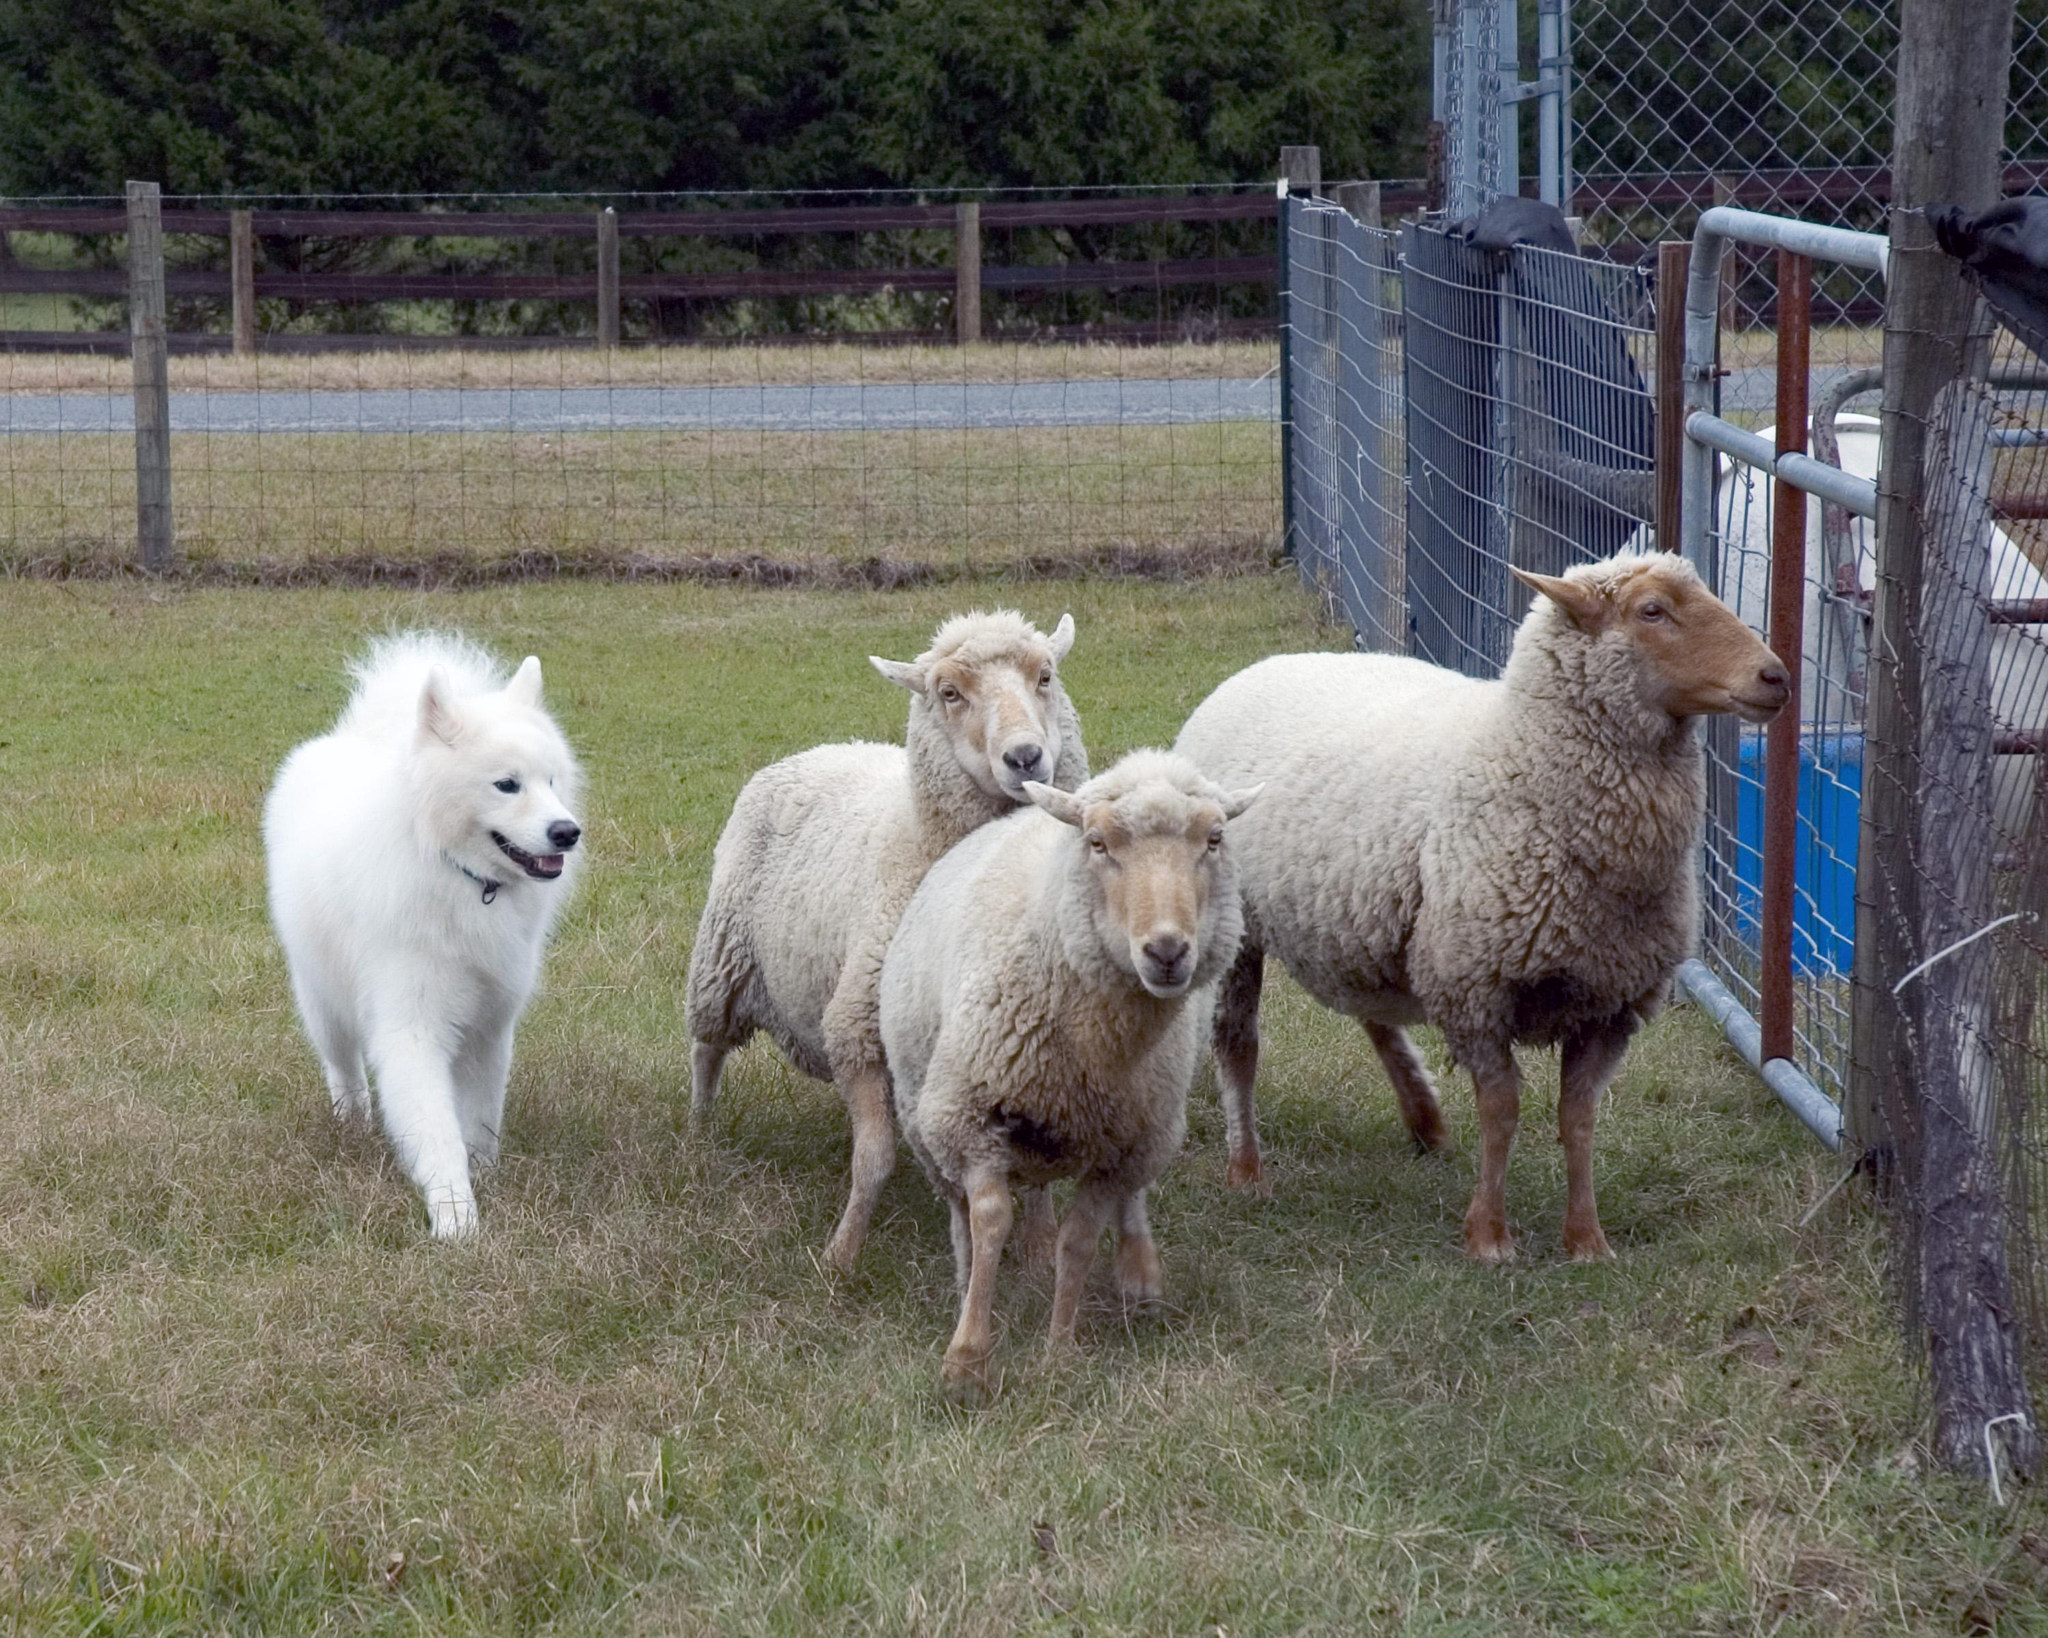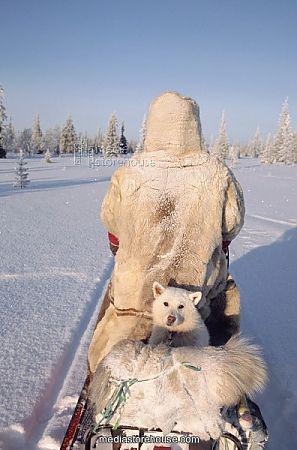The first image is the image on the left, the second image is the image on the right. For the images displayed, is the sentence "An image shows a white dog herding a group of sheep." factually correct? Answer yes or no. Yes. The first image is the image on the left, the second image is the image on the right. Evaluate the accuracy of this statement regarding the images: "A white dog rounds up some sheep in one of the images.". Is it true? Answer yes or no. Yes. 